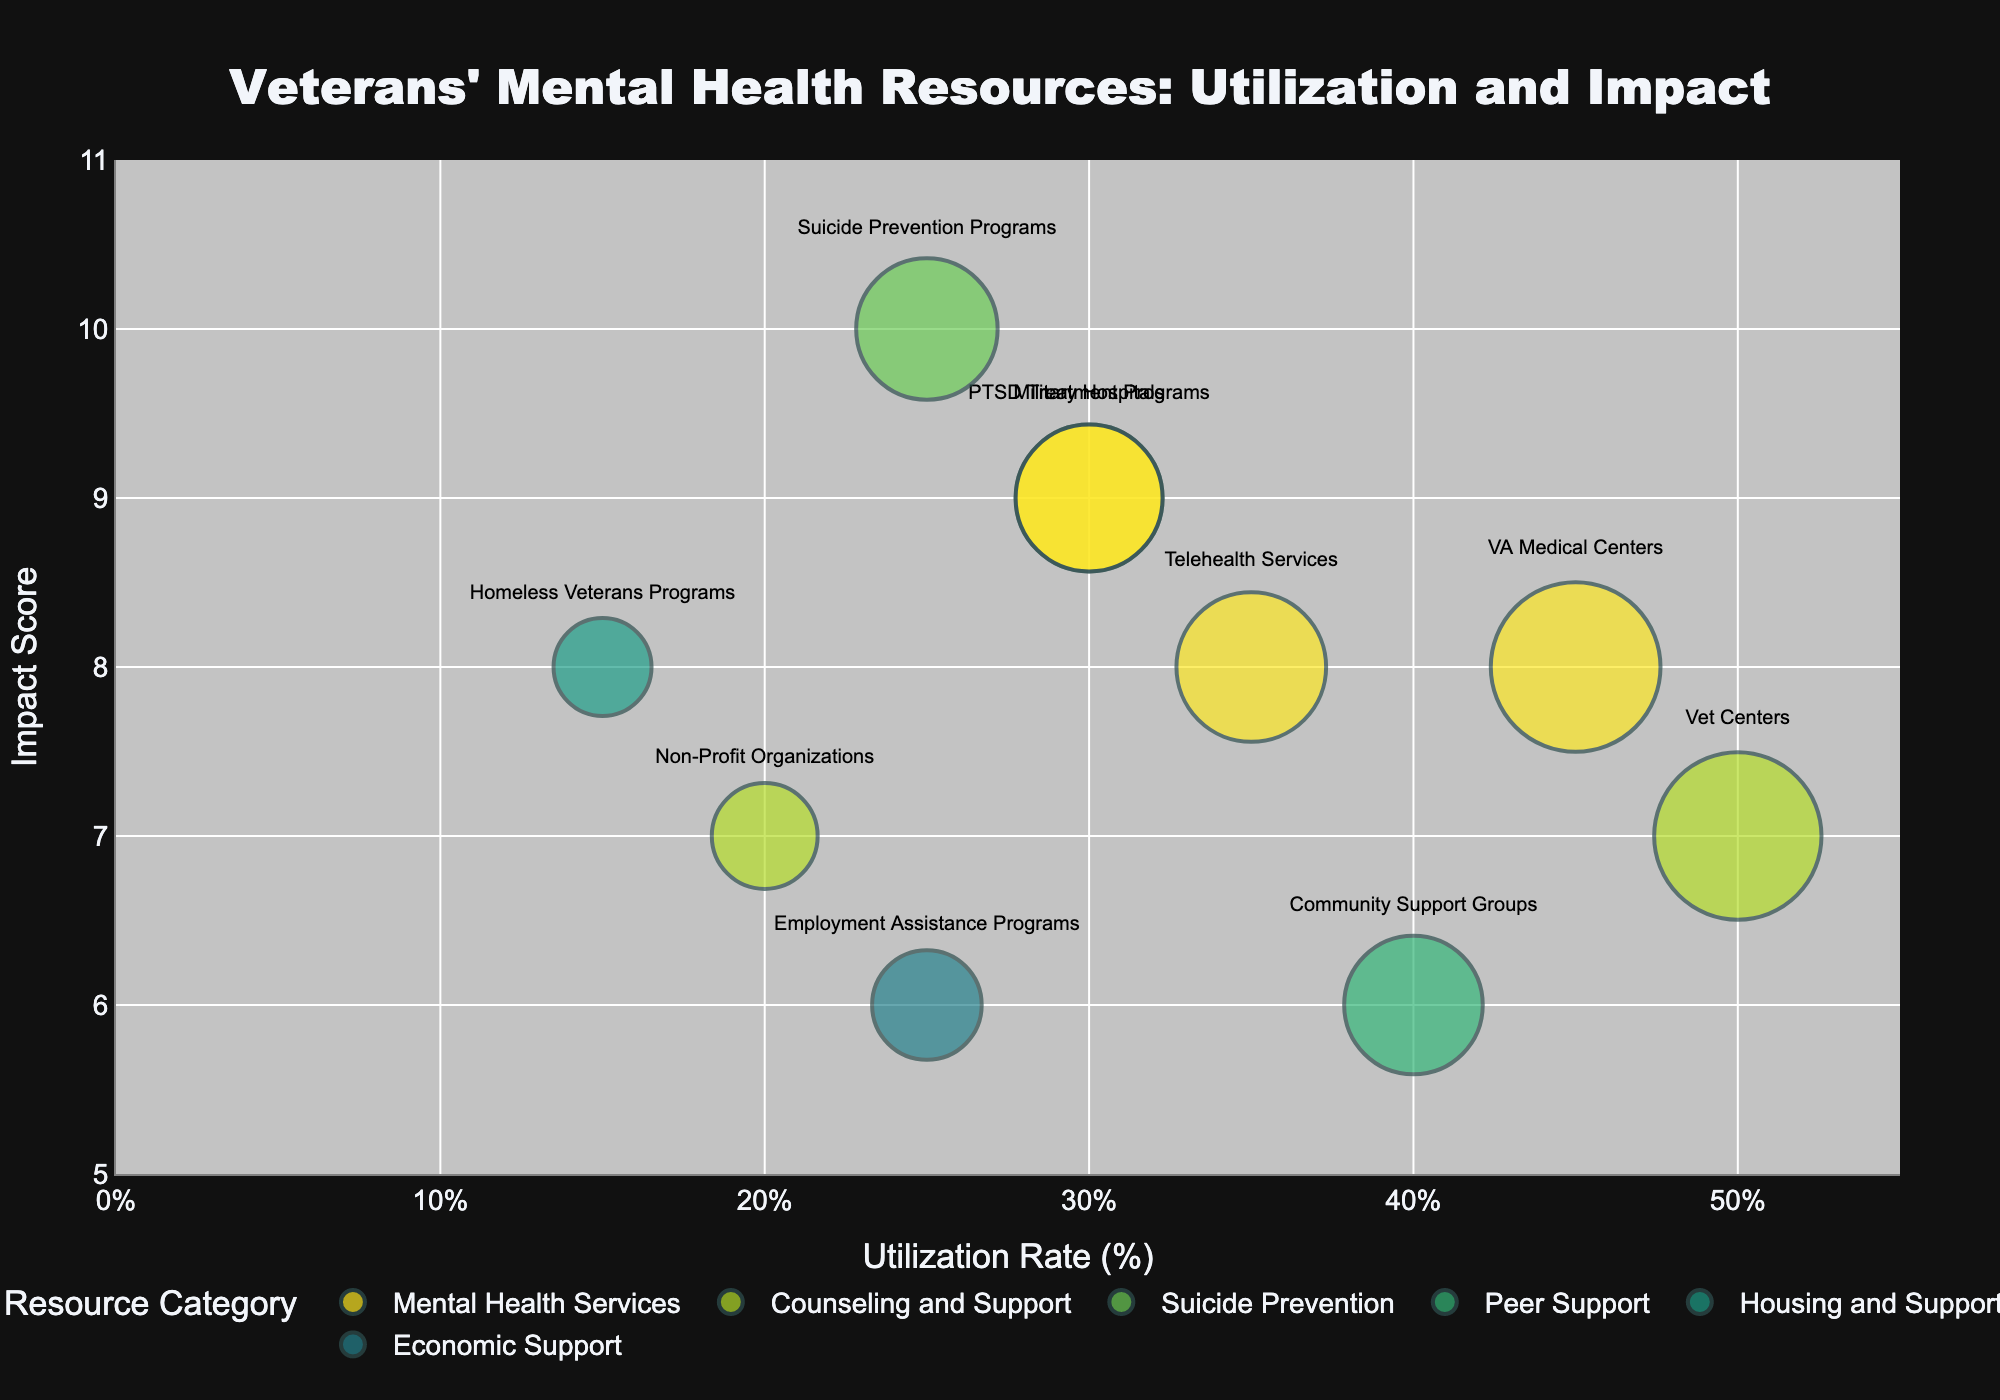What's the title of the bubble chart? The title of the chart is displayed prominently at the top center of the figure. The text is "Veterans' Mental Health Resources: Utilization and Impact".
Answer: Veterans' Mental Health Resources: Utilization and Impact What does the x-axis represent? The label on the x-axis reads "Utilization Rate (%)", indicating that this axis represents the percentage utilization rate of different resources.
Answer: Utilization Rate (%) What resource has the highest utilization rate? By examining the x-axis, the resource with the bubble furthest to the right has the highest utilization rate. The "Vet Centers" resource is at 50%.
Answer: Vet Centers Which resource category has the highest impact score? By looking at the y-axis, the resource placed highest vertically within each category represents the highest impact score. "Suicide Prevention Programs" in the "Suicide Prevention" category has the highest score of 10.
Answer: Suicide Prevention Programs What are the utilization rates and impact scores of "Telehealth Services" and "Military Hospitals"? Locate the bubbles for "Telehealth Services" and "Military Hospitals" and note their positions on the x and y axes to find their utilization rates and impact scores. "Telehealth Services" has a utilization rate of 35% and an impact score of 8, while "Military Hospitals" has a utilization rate of 30% and an impact score of 9.
Answer: Telehealth Services: 35%, 8; Military Hospitals: 30%, 9 Which resource has a higher bubble size, "VA Medical Centers" or "Community Support Groups"? Compare the sizes of the bubbles for "VA Medical Centers" and "Community Support Groups". "VA Medical Centers" has a larger bubble size of 360 compared to "Community Support Groups" with 240.
Answer: VA Medical Centers How many resources fall under the category "Counseling and Support"? Each bubble is color-coded by category. Counting the number of bubbles with the same color representing "Counseling and Support" shows that there are two: "Vet Centers" and "Non-Profit Organizations".
Answer: Two Which resource category is associated with the smallest bubble and what is its impact score? Identify the smallest bubble in the chart. The bubble for "Homeless Veterans Programs" is the smallest, corresponding to a bubble size of 120. The impact score for this resource is 8.
Answer: Homeless Veterans Programs; Impact Score: 8 What's the range of utilization rates for resources in the "Mental Health Services" category? Locate the bubbles within the "Mental Health Services" category and note their minimum and maximum x-axis positions. The resources are "VA Medical Centers" (45%), "PTSD Treatment Programs" (30%), "Telehealth Services" (35%), and "Military Hospitals" (30%), giving a range from 30% to 45%.
Answer: 30% to 45% Which resource in the "Economic Support" category has a utilization rate, and what is its impact score? There is only one resource under "Economic Support", which is "Employment Assistance Programs". It has a utilization rate of 25% and an impact score of 6.
Answer: Employment Assistance Programs; Utilization Rate: 25%, Impact Score: 6 